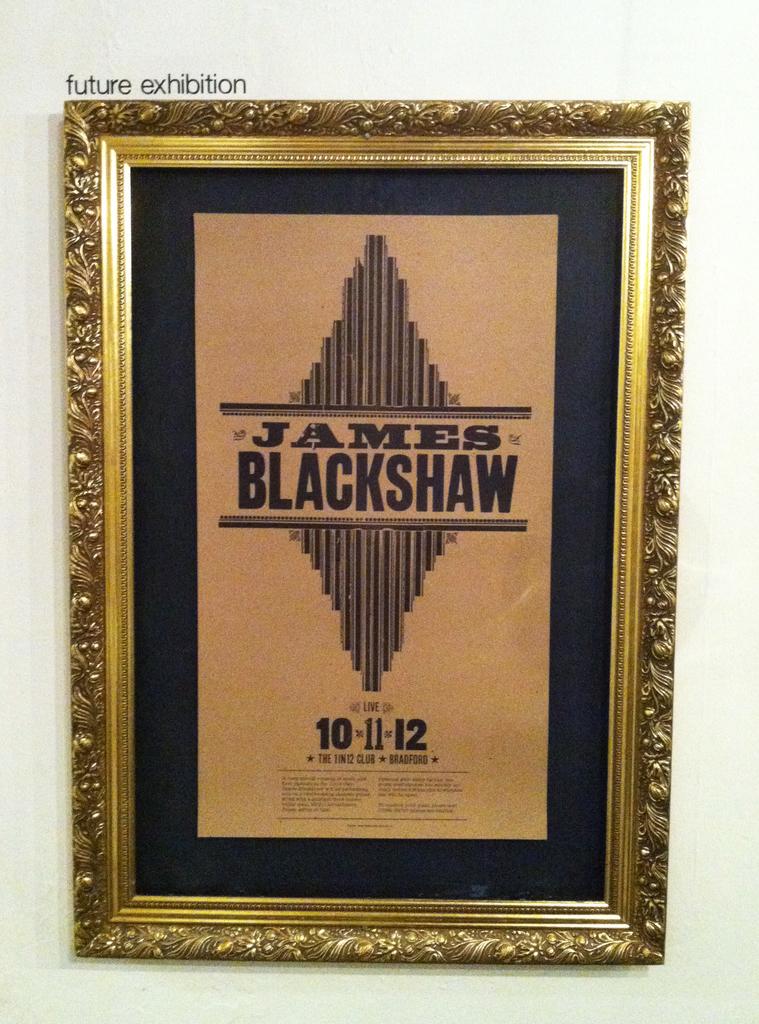What date is on the old piece of art?
Provide a succinct answer. 10-11-12. What is the name printed here?
Keep it short and to the point. James blackshaw. 